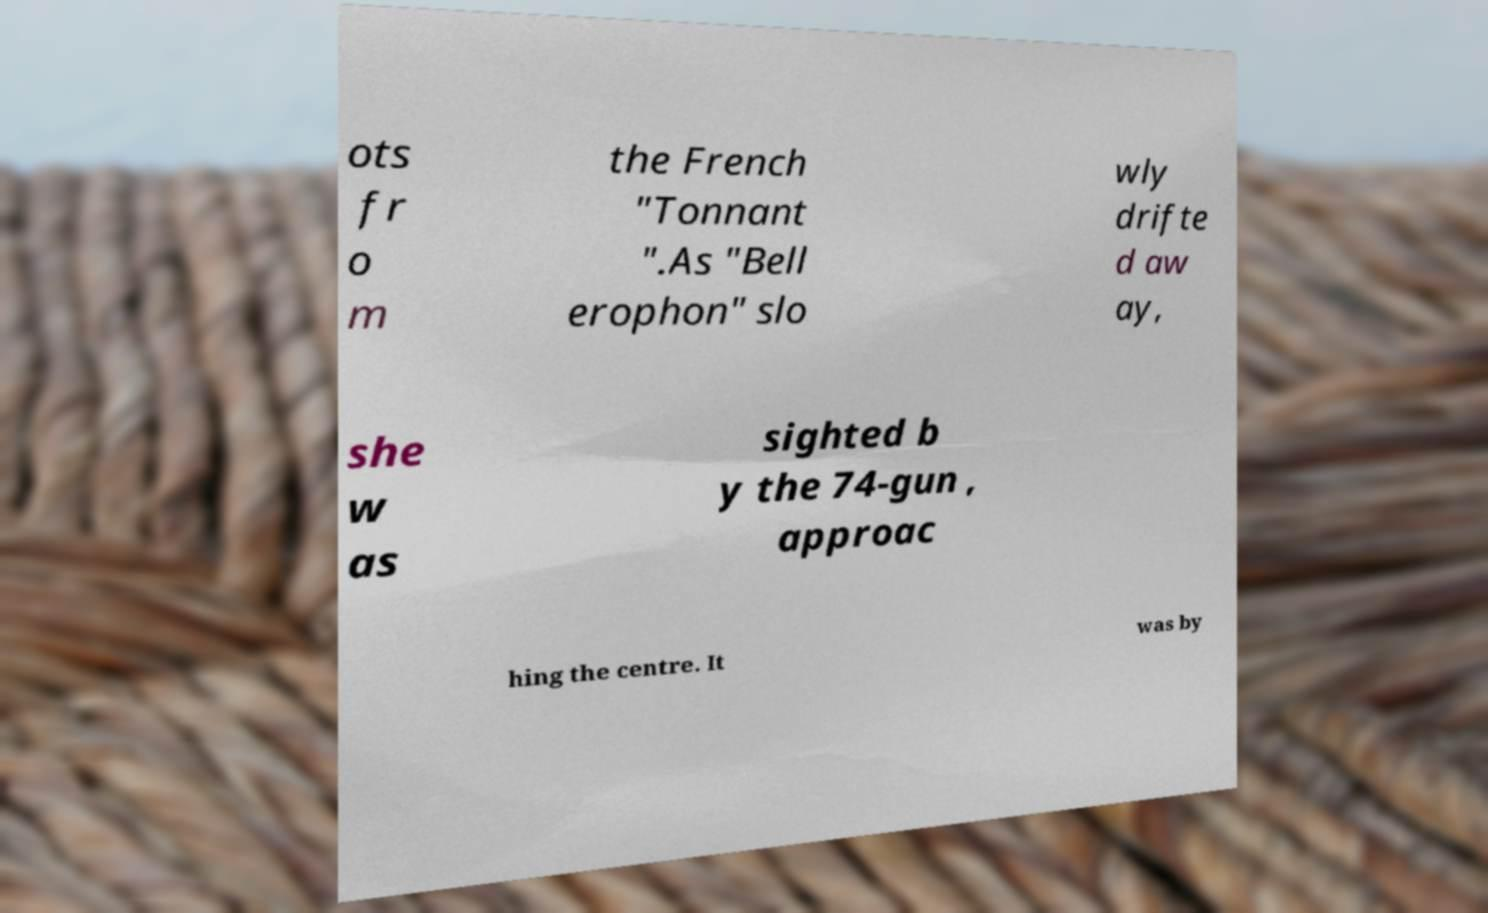Please read and relay the text visible in this image. What does it say? ots fr o m the French "Tonnant ".As "Bell erophon" slo wly drifte d aw ay, she w as sighted b y the 74-gun , approac hing the centre. It was by 